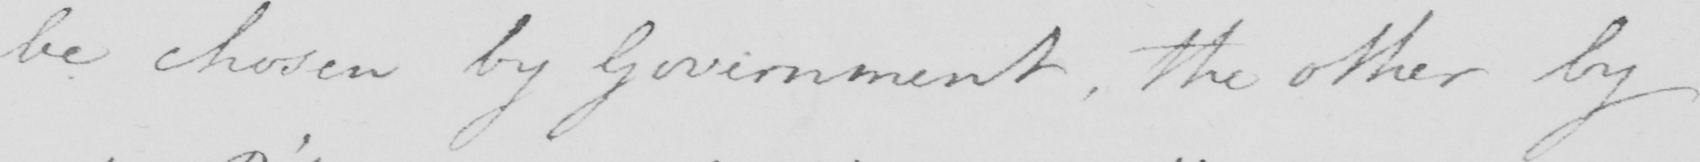What text is written in this handwritten line? be chosen by government , the other by 